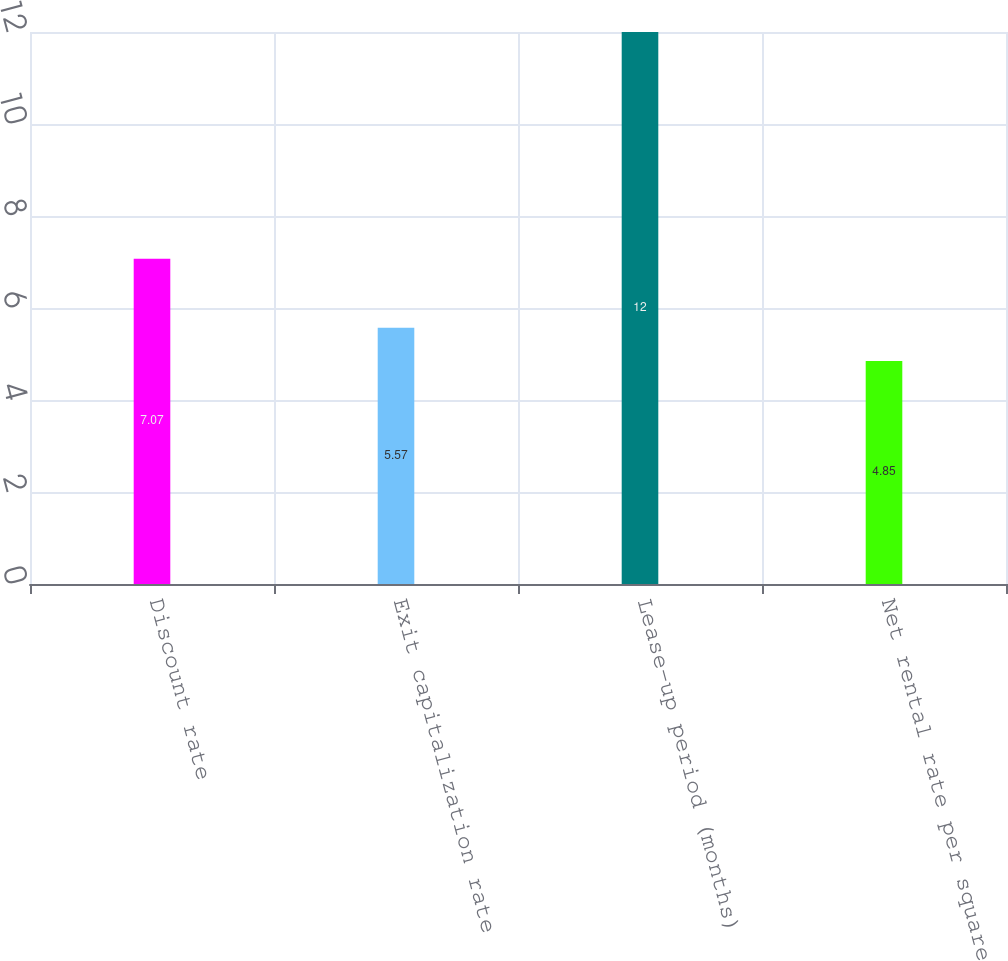Convert chart. <chart><loc_0><loc_0><loc_500><loc_500><bar_chart><fcel>Discount rate<fcel>Exit capitalization rate<fcel>Lease-up period (months)<fcel>Net rental rate per square<nl><fcel>7.07<fcel>5.57<fcel>12<fcel>4.85<nl></chart> 